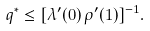<formula> <loc_0><loc_0><loc_500><loc_500>q ^ { * } \leq [ \lambda ^ { \prime } ( 0 ) \, \rho ^ { \prime } ( 1 ) ] ^ { - 1 } .</formula> 